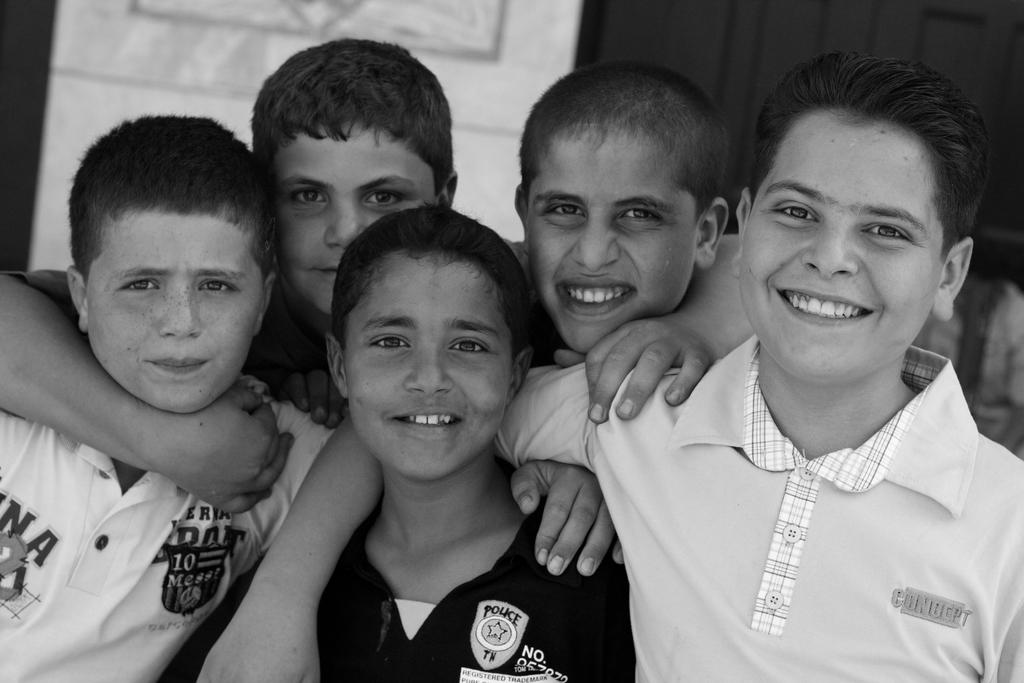What is the color scheme of the image? The image is black and white. How many children are present in the image? There are many children in the image. What is the emotional state of some of the children? Some of the children are smiling. What type of pies are the children eating in the image? There is no indication in the image that the children are eating any pies. Where is the park located in the image? There is no park present in the image. What book is the child reading in the image? There is no book or child reading in the image. 